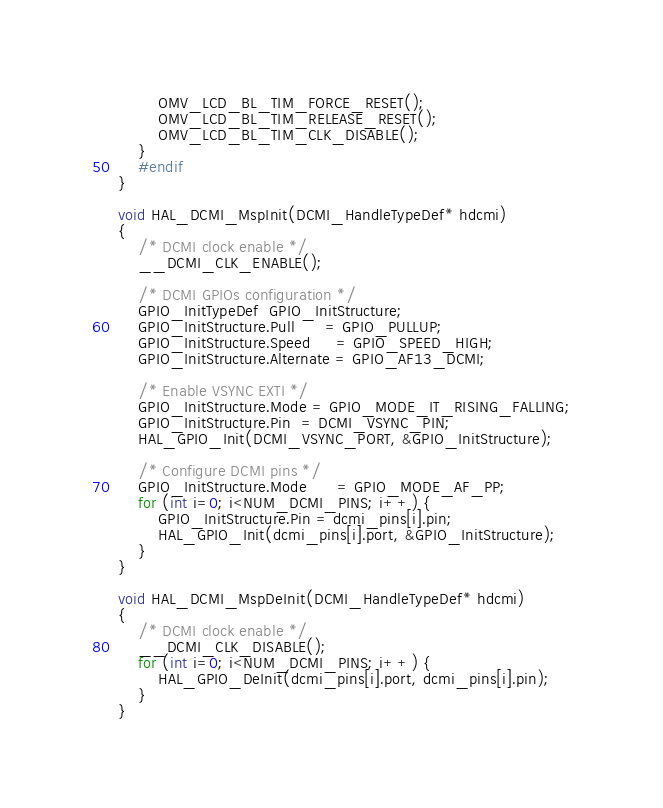<code> <loc_0><loc_0><loc_500><loc_500><_C_>        OMV_LCD_BL_TIM_FORCE_RESET();
        OMV_LCD_BL_TIM_RELEASE_RESET();
        OMV_LCD_BL_TIM_CLK_DISABLE();
    }
    #endif
}

void HAL_DCMI_MspInit(DCMI_HandleTypeDef* hdcmi)
{
    /* DCMI clock enable */
    __DCMI_CLK_ENABLE();

    /* DCMI GPIOs configuration */
    GPIO_InitTypeDef  GPIO_InitStructure;
    GPIO_InitStructure.Pull      = GPIO_PULLUP;
    GPIO_InitStructure.Speed     = GPIO_SPEED_HIGH;
    GPIO_InitStructure.Alternate = GPIO_AF13_DCMI;

    /* Enable VSYNC EXTI */
    GPIO_InitStructure.Mode = GPIO_MODE_IT_RISING_FALLING;
    GPIO_InitStructure.Pin  = DCMI_VSYNC_PIN;
    HAL_GPIO_Init(DCMI_VSYNC_PORT, &GPIO_InitStructure);

    /* Configure DCMI pins */
    GPIO_InitStructure.Mode      = GPIO_MODE_AF_PP;
    for (int i=0; i<NUM_DCMI_PINS; i++) {
        GPIO_InitStructure.Pin = dcmi_pins[i].pin;
        HAL_GPIO_Init(dcmi_pins[i].port, &GPIO_InitStructure);
    }
}

void HAL_DCMI_MspDeInit(DCMI_HandleTypeDef* hdcmi)
{
    /* DCMI clock enable */
    __DCMI_CLK_DISABLE();
    for (int i=0; i<NUM_DCMI_PINS; i++) {
        HAL_GPIO_DeInit(dcmi_pins[i].port, dcmi_pins[i].pin);
    }
}

</code> 